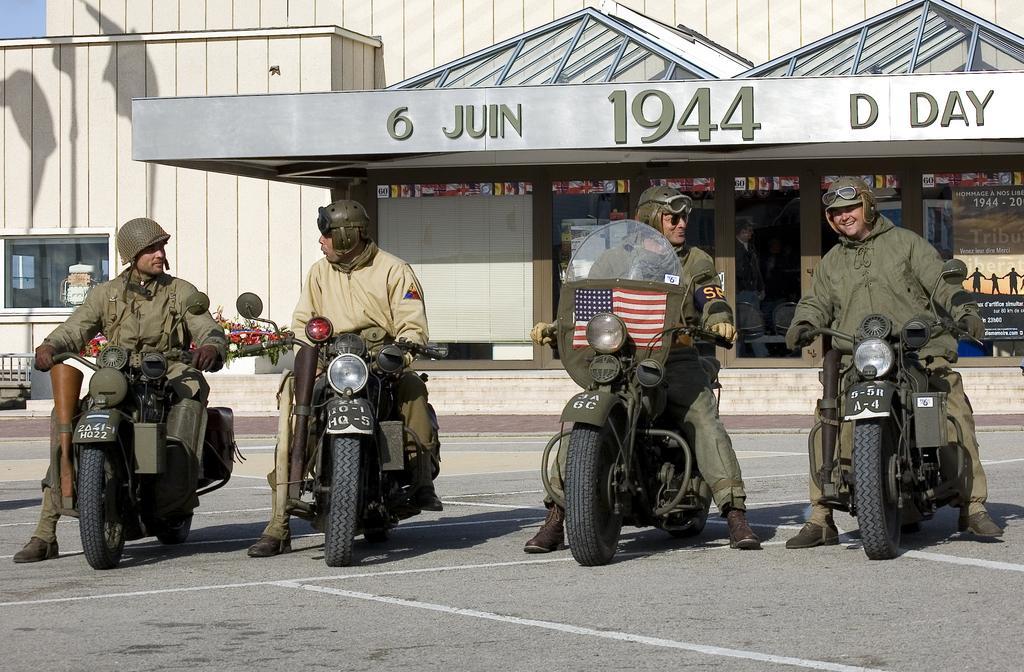Could you give a brief overview of what you see in this image? In this image I can see four men are sitting on their bikes, I can also see smile on few faces. I can see all of them are wearing helmets, goggles and jackets. In the background I can see a building and here I can see a flag. 